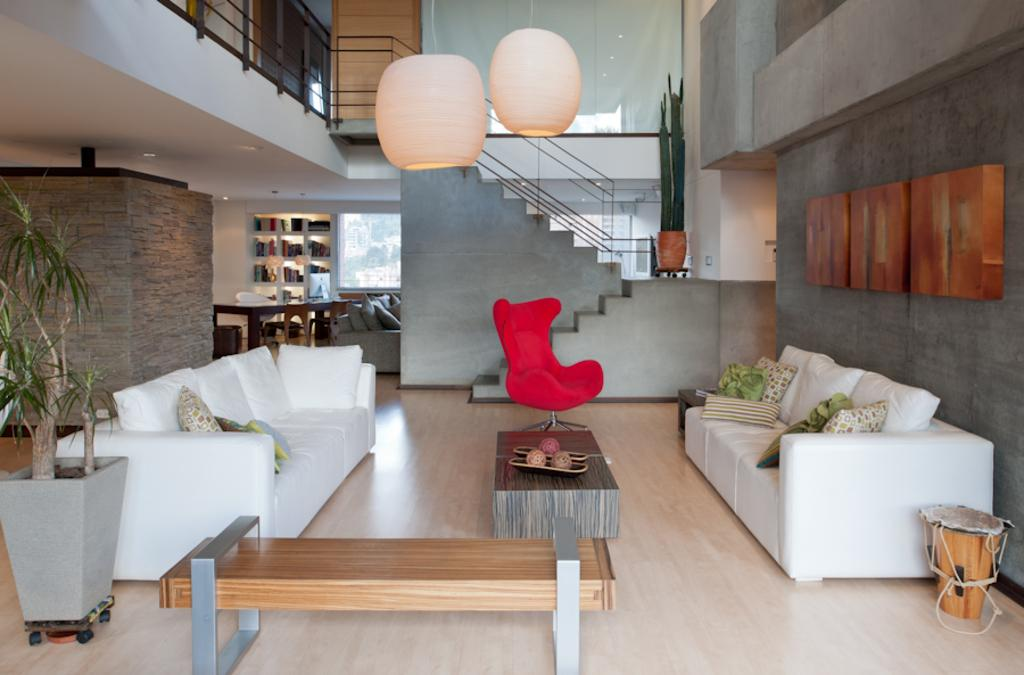What type of seating is present on either side of the table in the image? There are two white sofas on either side of the table in the image. What is located between the sofas? There is a table between the sofas. What other type of seating is present between the sofas? There is a red chair between the sofas. What can be seen in the background of the image? There is a staircase and a bookshelf in the background. What type of bone is visible on the table between the sofas? There is no bone present on the table between the sofas in the image. Can you tell me how many railway tracks are visible in the background? There are no railway tracks visible in the background of the image; it features a staircase and a bookshelf. 